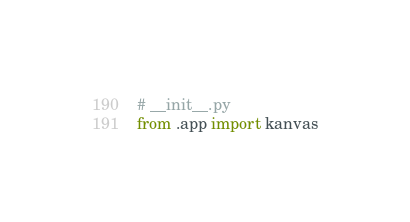Convert code to text. <code><loc_0><loc_0><loc_500><loc_500><_Python_># __init__.py
from .app import kanvas</code> 